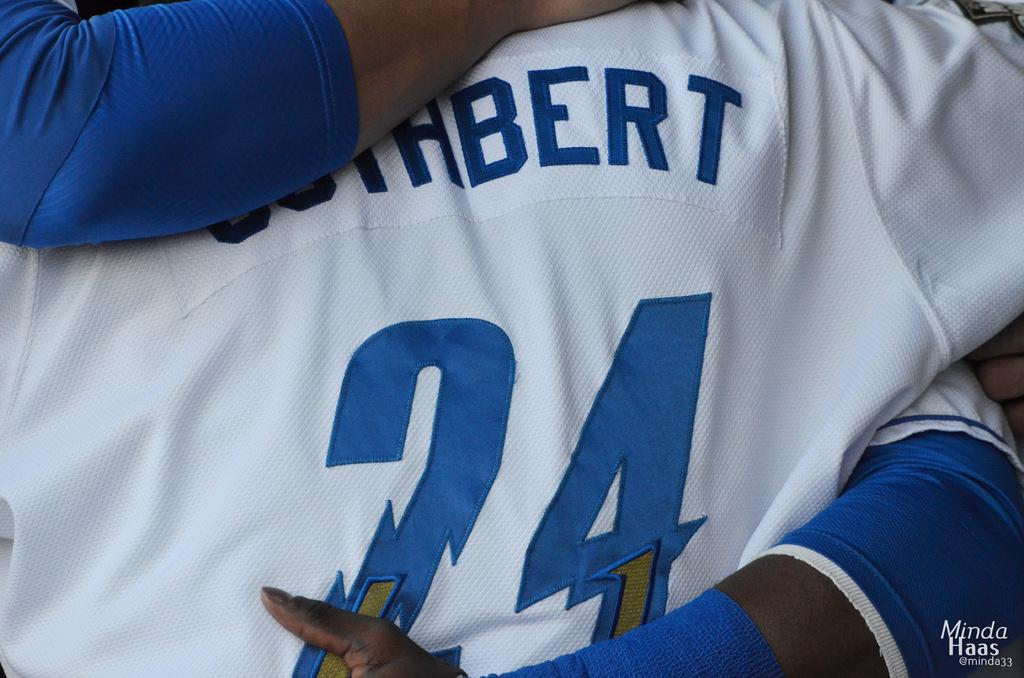Provide a one-sentence caption for the provided image. "24" is on a white and blue jersey. 